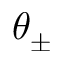<formula> <loc_0><loc_0><loc_500><loc_500>\theta _ { \pm }</formula> 